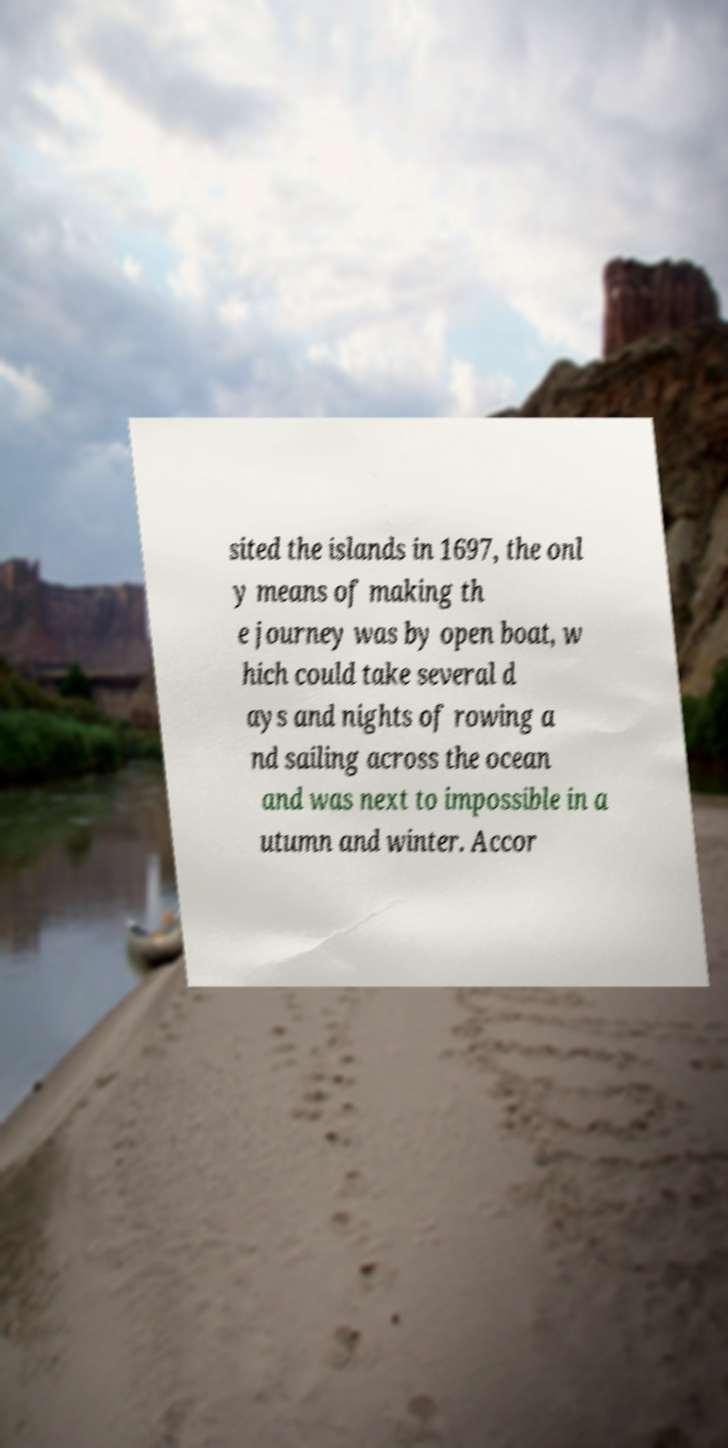There's text embedded in this image that I need extracted. Can you transcribe it verbatim? sited the islands in 1697, the onl y means of making th e journey was by open boat, w hich could take several d ays and nights of rowing a nd sailing across the ocean and was next to impossible in a utumn and winter. Accor 